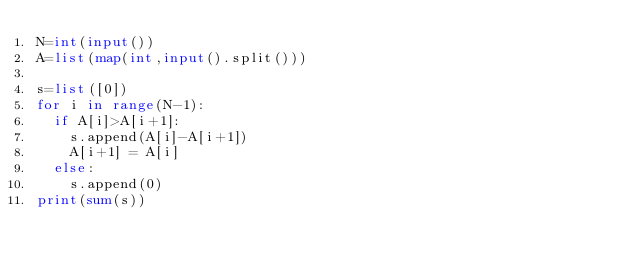<code> <loc_0><loc_0><loc_500><loc_500><_Python_>N=int(input())
A=list(map(int,input().split()))

s=list([0])
for i in range(N-1):
  if A[i]>A[i+1]:
    s.append(A[i]-A[i+1])
    A[i+1] = A[i]
  else:
    s.append(0)
print(sum(s))</code> 